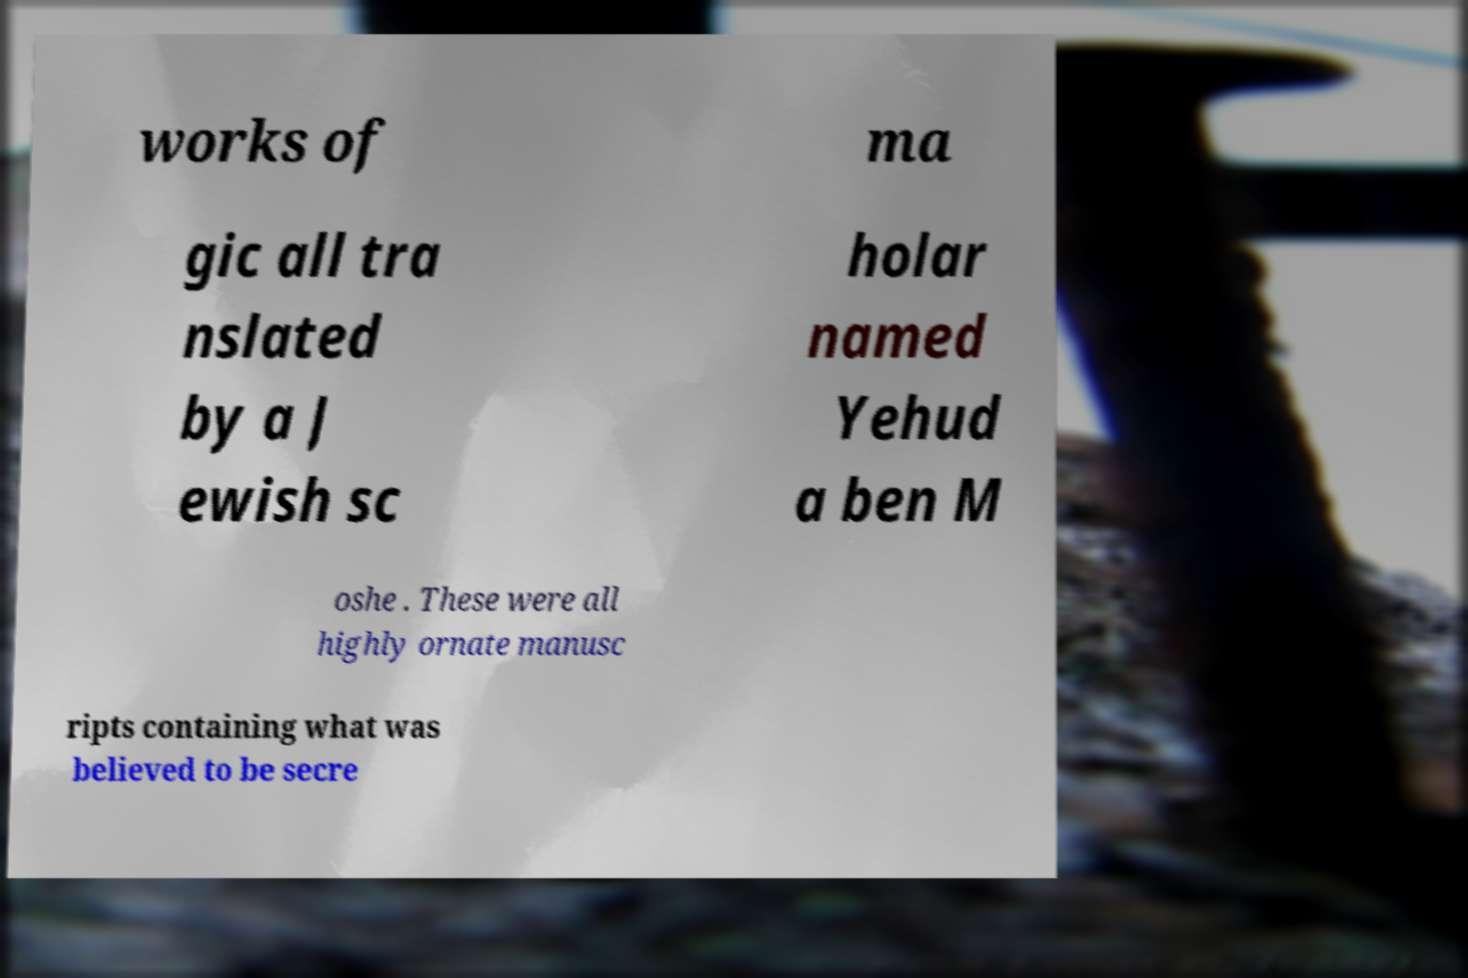Can you accurately transcribe the text from the provided image for me? works of ma gic all tra nslated by a J ewish sc holar named Yehud a ben M oshe . These were all highly ornate manusc ripts containing what was believed to be secre 